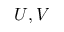<formula> <loc_0><loc_0><loc_500><loc_500>U , V</formula> 